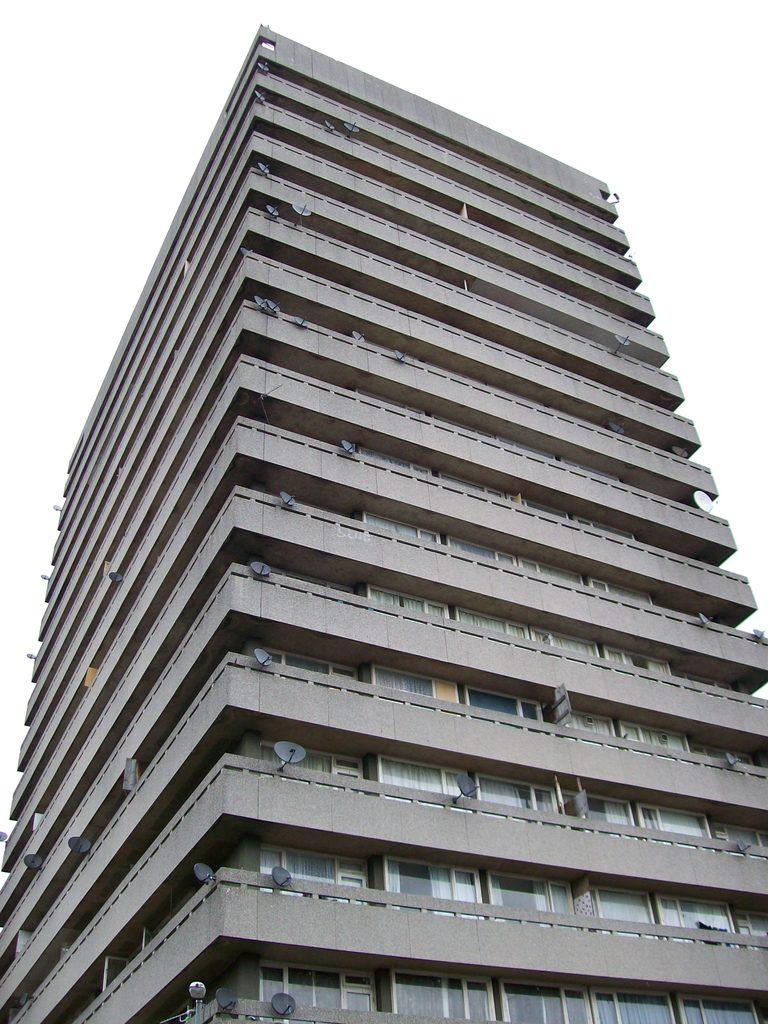What type of structure is the main subject in the image? There is a tall building in the image. Can you describe the building's features? The building has multiple floors. What can be seen in the background of the image? There is a sky visible in the background of the image. What type of quilt is being used to cover the building in the image? There is no quilt present in the image; it features a tall building with multiple floors and a sky visible in the background. 